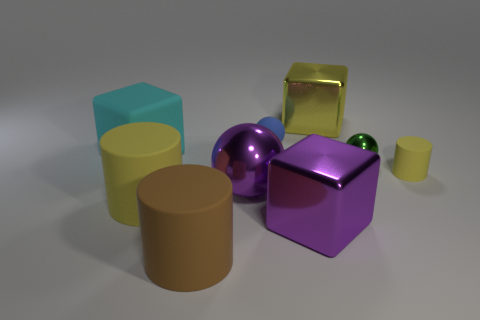What number of other objects are there of the same color as the small metallic object?
Keep it short and to the point. 0. Are there an equal number of big yellow metal blocks in front of the purple metal ball and large cyan blocks?
Ensure brevity in your answer.  No. There is a big yellow thing to the left of the shiny thing that is behind the rubber ball; what number of metallic objects are in front of it?
Offer a terse response. 1. There is a green thing; is its size the same as the ball behind the big cyan cube?
Keep it short and to the point. Yes. What number of large brown matte cylinders are there?
Keep it short and to the point. 1. Does the matte cylinder that is in front of the purple block have the same size as the matte cylinder on the right side of the tiny blue ball?
Ensure brevity in your answer.  No. The small shiny object that is the same shape as the blue rubber thing is what color?
Your response must be concise. Green. Is the blue thing the same shape as the green shiny thing?
Offer a very short reply. Yes. There is a green metal thing that is the same shape as the small blue object; what is its size?
Your answer should be compact. Small. What number of small yellow cylinders have the same material as the brown cylinder?
Offer a very short reply. 1. 